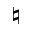<formula> <loc_0><loc_0><loc_500><loc_500>\natural</formula> 